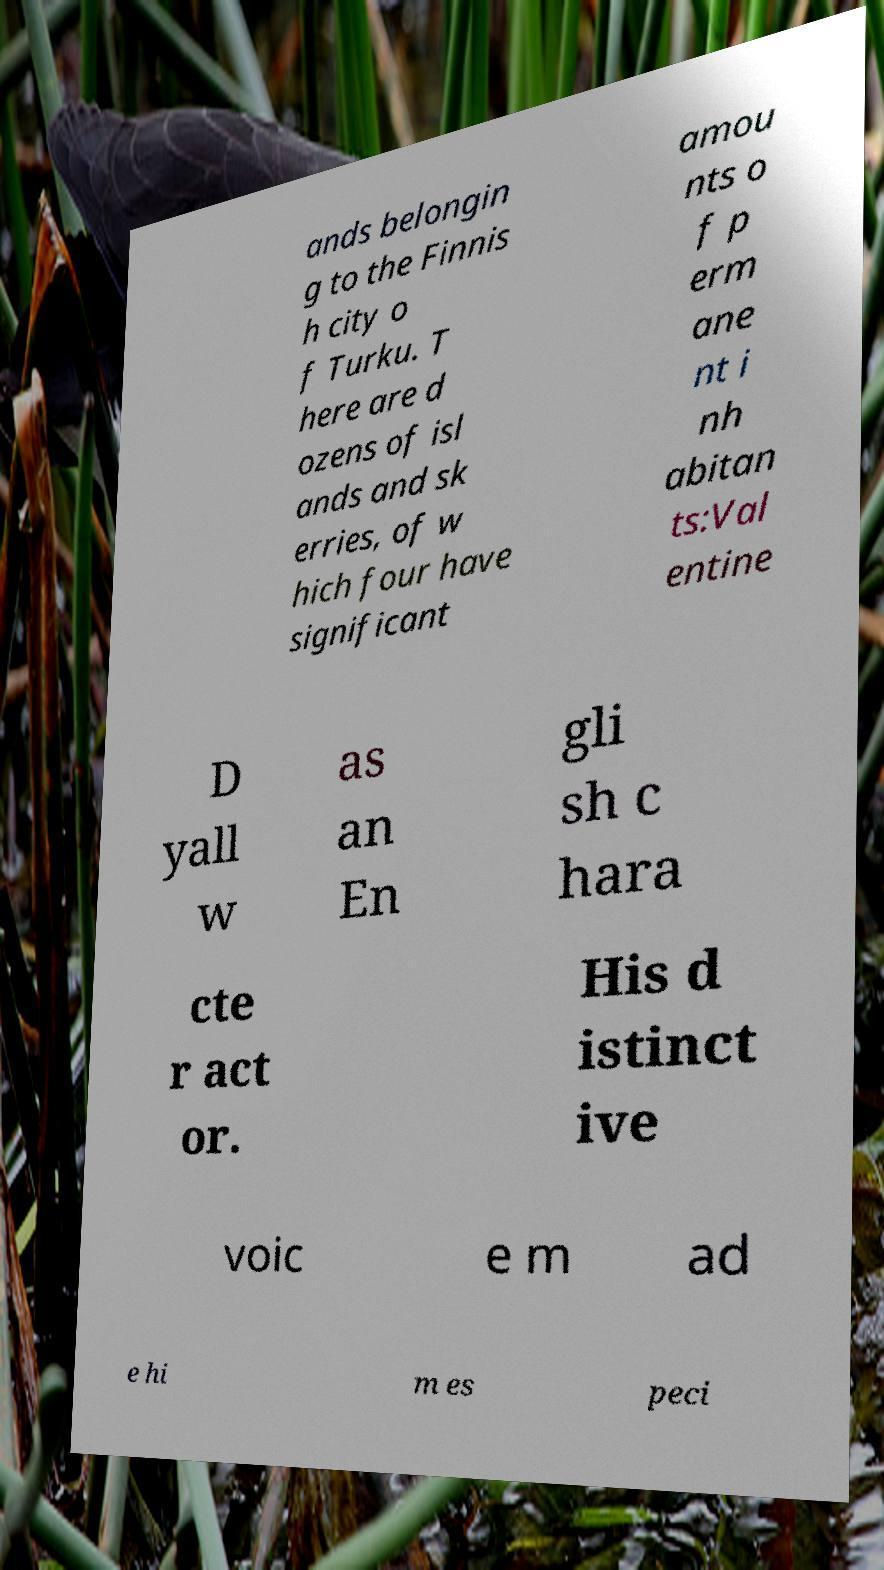Could you extract and type out the text from this image? ands belongin g to the Finnis h city o f Turku. T here are d ozens of isl ands and sk erries, of w hich four have significant amou nts o f p erm ane nt i nh abitan ts:Val entine D yall w as an En gli sh c hara cte r act or. His d istinct ive voic e m ad e hi m es peci 